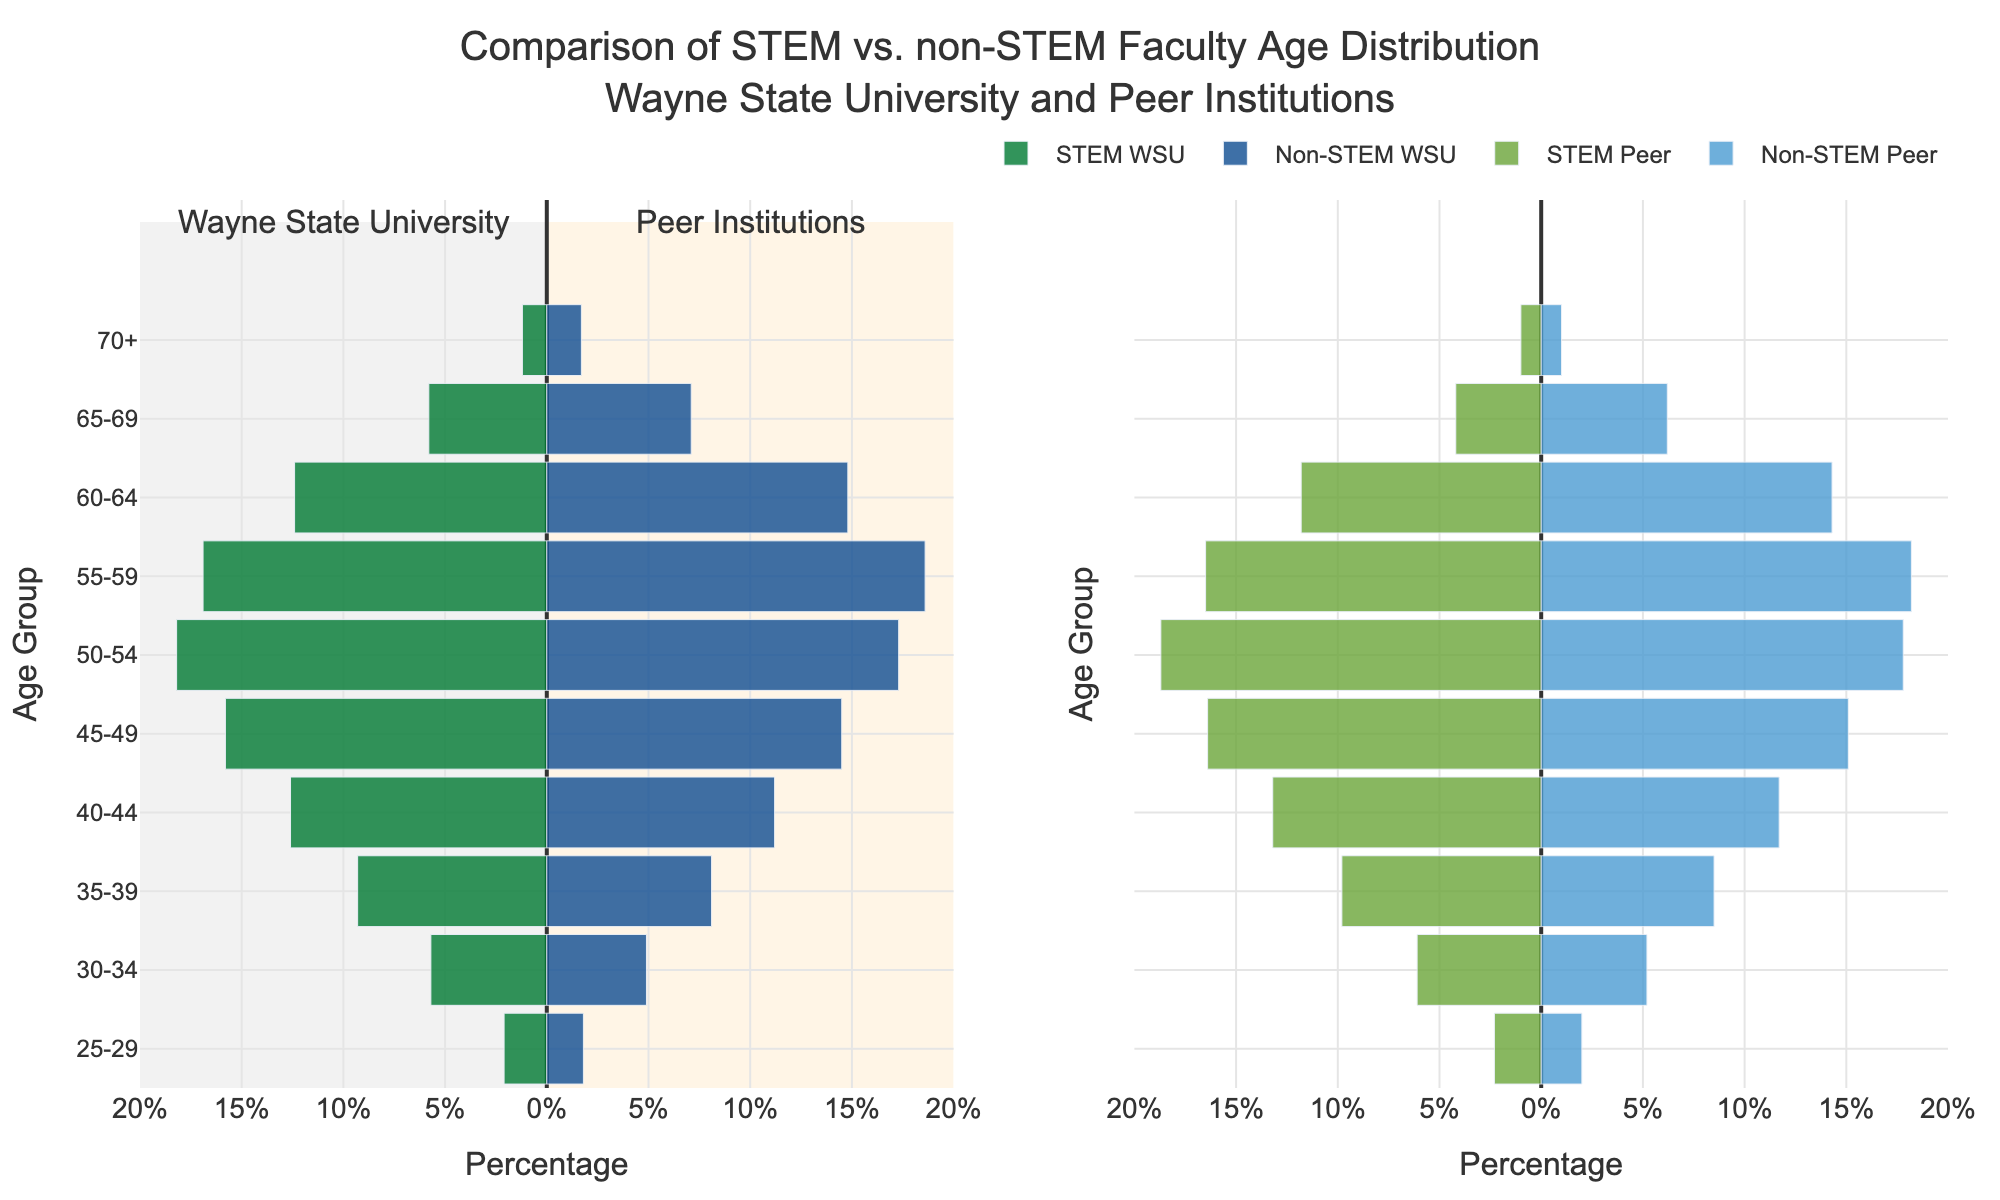How does the title describe the contents of the plot? The title indicates that the plot compares the age distribution of STEM versus non-STEM faculty members at Wayne State University (WSU) and its peer institutions.
Answer: Comparison of STEM vs. non-STEM Faculty Age Distribution at Wayne State University and Peer Institutions What is the age group with the highest percentage of faculty in the STEM category at Wayne State University? To find the highest percentage, look at the bars in the STEM WSU section. The 50-54 age group has the longest bar at 18.2%.
Answer: 50-54 What can be inferred from the distribution of non-STEM faculty aged 60-64 at peer institutions compared to WSU? Comparing the non-STEM WSU bar (14.8%) and non-STEM Peer bar (14.3%) for the 60-64 group shows that WSU has a slightly higher percentage.
Answer: WSU has a slightly higher percentage Which age group shows the largest difference in percentage between STEM WSU and non-STEM WSU faculty? The age group with the largest discrepancy is 65-69, where non-STEM faculty are at 7.1%, while STEM faculty are at 5.8%, showing a difference of 1.3%.
Answer: 65-69 Are there more faculty over 60 years old in the non-STEM category at WSU or its peer institutions? For the non-STEM category, sum the percentages for age groups 60-64 and 65-69 for both WSU and peers. At WSU, it is 14.8% + 7.1% = 21.9%. At peer institutions, it is 14.3% + 6.2% = 20.5%, meaning WSU has more non-STEM faculty over 60 years old.
Answer: WSU How do STEM faculty at peer institutions compare to WSU in the 45-49 age group? Compare the STEM WSU bar (15.8%) with the STEM Peer bar (16.4%) for the 45-49 age group. Peer institutions have a higher percentage.
Answer: Peer institutions have a higher percentage What is the trend for faculty aged 55-59 in the non-STEM category across WSU and peer institutions? Check the bars for the 55-59 age group. Both WSU (18.6%) and Peer (18.2%) have high percentages compared to other age groups, indicating that this age range is well represented in both.
Answer: Both have high percentages Which constituent (STEM or non-STEM at WSU or Peer) has the lowest percentage of faculty in any age group? Identify the smallest percentage in any category. STEM Peer faculty aged 70+ have the lowest percentage at 1.0%.
Answer: STEM Peer faculty aged 70+ 